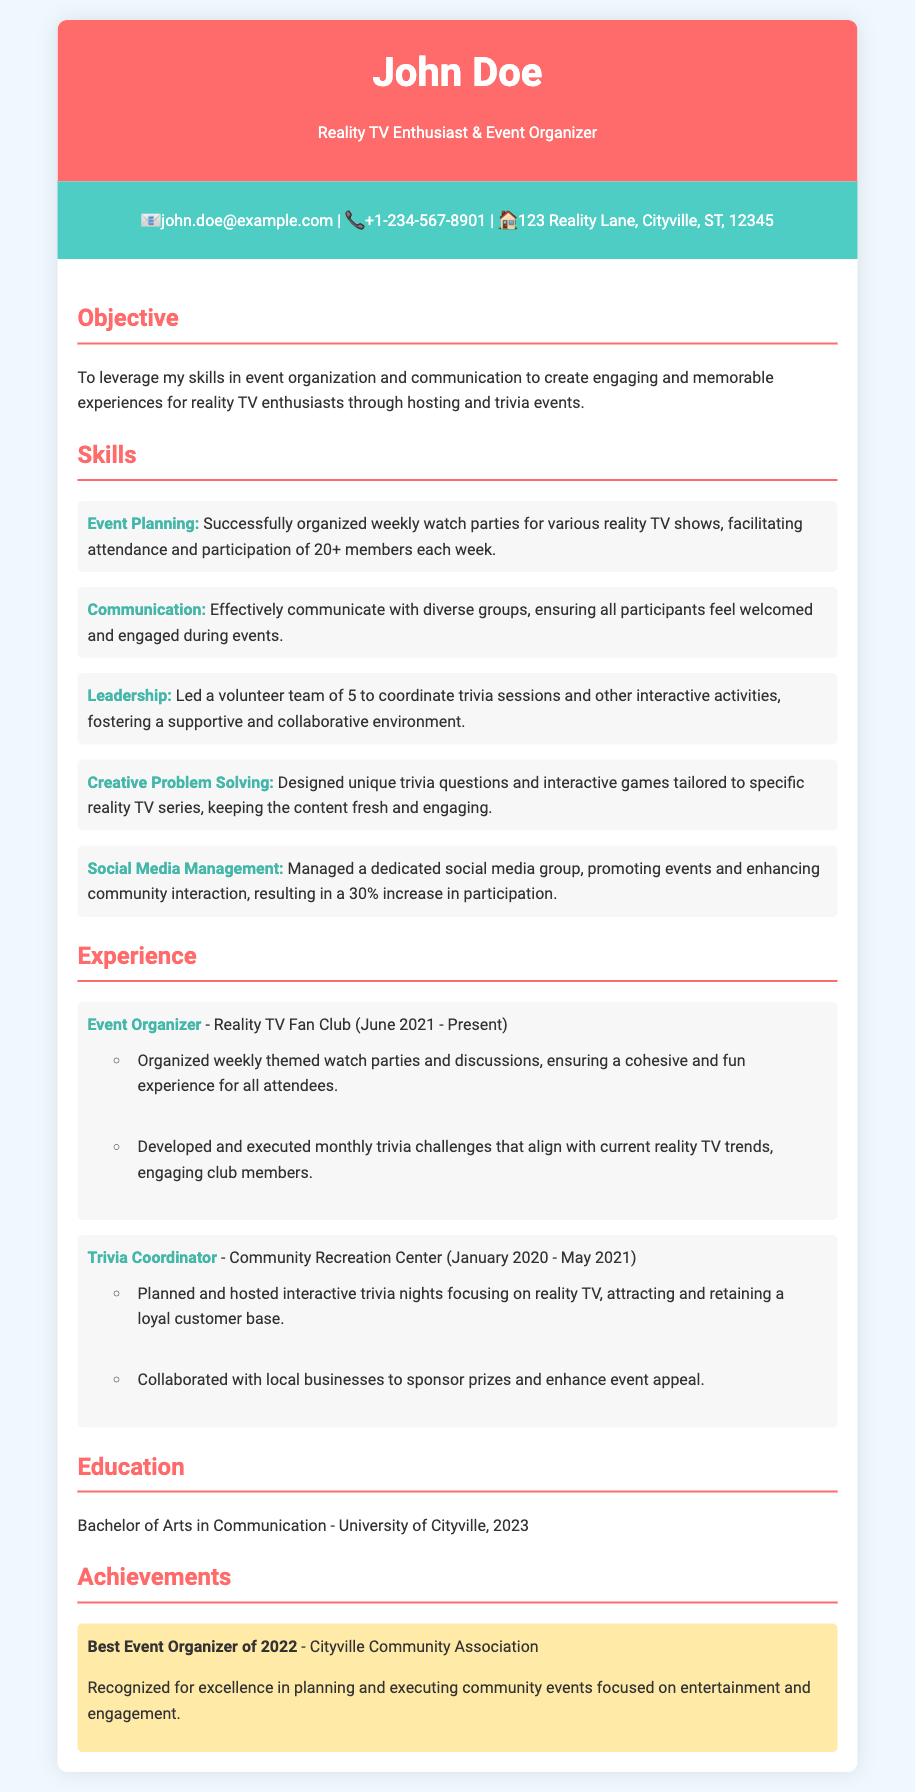What is the name of the individual in the CV? The individual's name is presented prominently at the top of the document.
Answer: John Doe What is the primary objective mentioned in the CV? The objective outlines the individual's intentions for leveraging their skills.
Answer: Create engaging and memorable experiences What is the email address provided in the contact information? The contact information section lists the individual's email address directly.
Answer: john.doe@example.com How many skills are listed in the CV? The skills section contains a total of five individual skills listed.
Answer: 5 What award did John Doe receive in 2022? The achievement section highlights a specific recognition awarded to the individual.
Answer: Best Event Organizer During which years did John Doe work as a Trivia Coordinator? The experience section specifies the timeframe of that role.
Answer: January 2020 - May 2021 What position does John Doe currently hold? The first experience entry in the document states the individual's current role.
Answer: Event Organizer What was the percentage increase in participation mentioned in the skills section? The social media management skill details the increase in community interaction.
Answer: 30% 